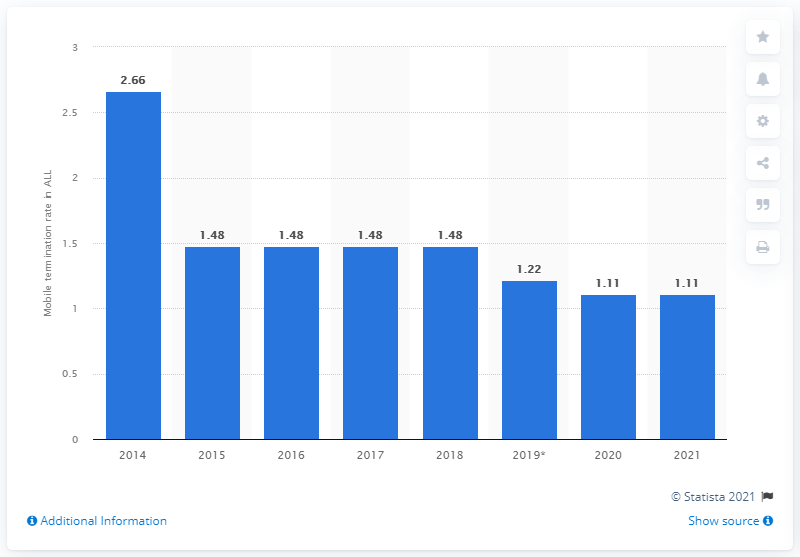Give some essential details in this illustration. In 2014, Vodafone's mobile termination rate in Albania was 2.66. In 2014, Vodafone's mobile termination rate in Albania was 2014. By 2021, this rate had decreased. 